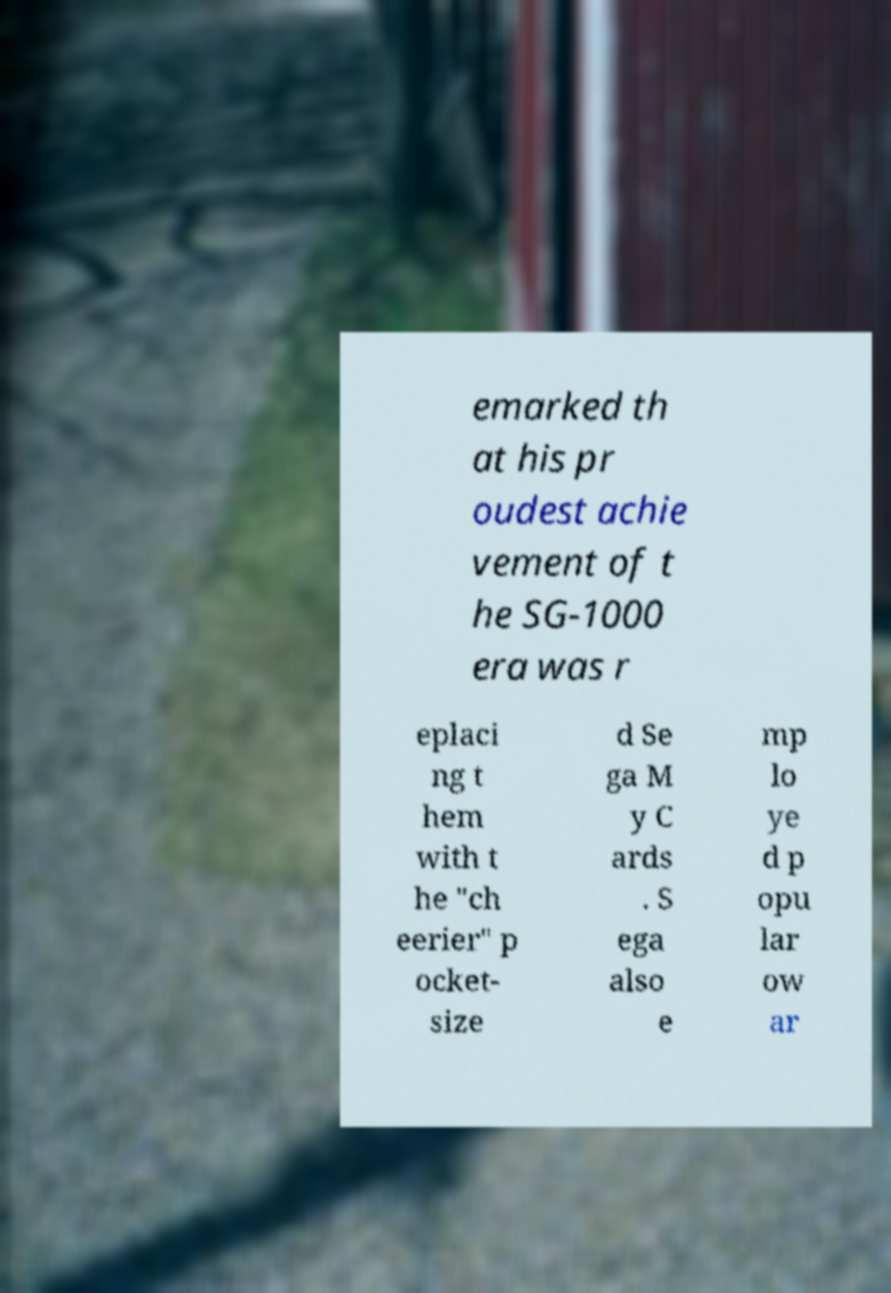Please read and relay the text visible in this image. What does it say? emarked th at his pr oudest achie vement of t he SG-1000 era was r eplaci ng t hem with t he "ch eerier" p ocket- size d Se ga M y C ards . S ega also e mp lo ye d p opu lar ow ar 